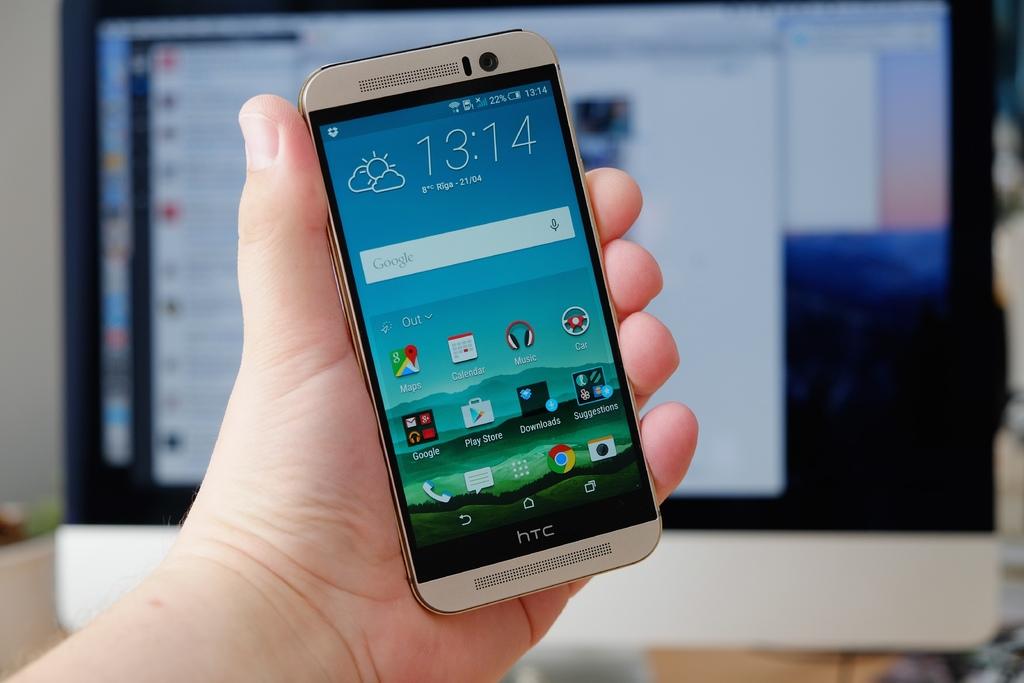What brand of phone is this?
Your response must be concise. Htc. Is the time on the phone in military time?
Your answer should be compact. 13:14. 